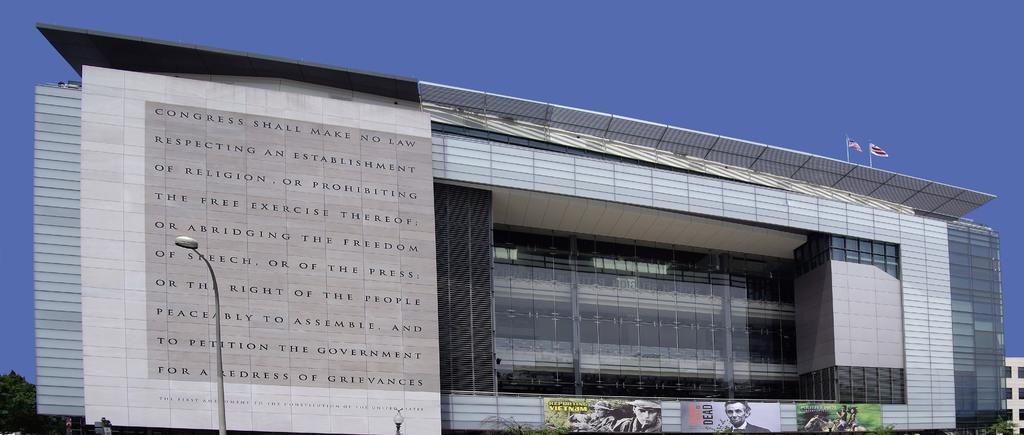How would you summarize this image in a sentence or two? In this image I can see a building in the centre and in the front of it I can see few posts, few trees, few poles and few lights. I can also see a tree on the left side and on the right side I can see one more building. On the top of this image I can see few flags on the building and in the background I can see the sky. I can also see something is written on the left side of the building. 